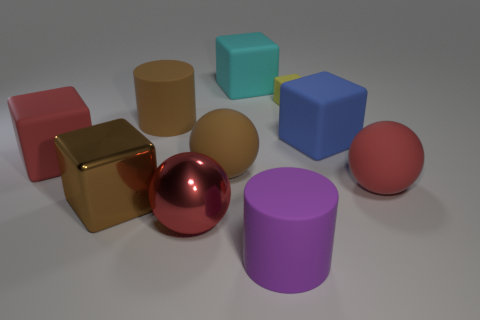Are there any other things that are the same size as the yellow block?
Provide a short and direct response. No. Are any tiny red blocks visible?
Ensure brevity in your answer.  No. Is the yellow object the same shape as the large cyan object?
Offer a terse response. Yes. How many large brown cylinders are in front of the big matte sphere that is on the left side of the big red object that is right of the purple thing?
Make the answer very short. 0. There is a block that is both in front of the large brown cylinder and to the right of the big purple rubber thing; what is it made of?
Give a very brief answer. Rubber. What color is the large block that is in front of the large blue rubber thing and behind the metal cube?
Your answer should be compact. Red. Are there any other things of the same color as the small matte object?
Your answer should be compact. No. There is a large red matte thing right of the big matte cylinder that is in front of the large cylinder that is to the left of the big purple rubber cylinder; what shape is it?
Provide a succinct answer. Sphere. What is the color of the other big rubber thing that is the same shape as the big purple thing?
Your response must be concise. Brown. There is a small rubber block that is on the right side of the rubber sphere that is left of the purple thing; what is its color?
Provide a succinct answer. Yellow. 